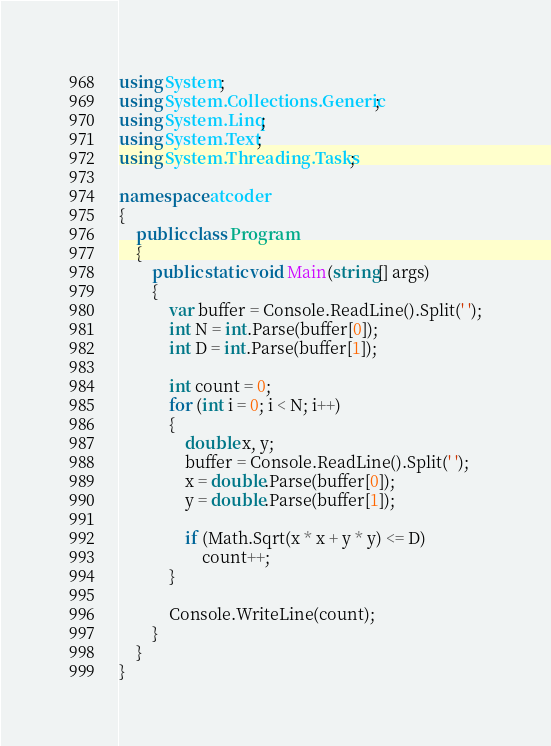Convert code to text. <code><loc_0><loc_0><loc_500><loc_500><_C#_>using System;
using System.Collections.Generic;
using System.Linq;
using System.Text;
using System.Threading.Tasks;

namespace atcoder
{
    public class Program
    {
        public static void Main(string[] args)
        {
            var buffer = Console.ReadLine().Split(' ');
            int N = int.Parse(buffer[0]);
            int D = int.Parse(buffer[1]);

            int count = 0;
            for (int i = 0; i < N; i++)
            {
                double x, y;
                buffer = Console.ReadLine().Split(' ');
                x = double.Parse(buffer[0]);
                y = double.Parse(buffer[1]);

                if (Math.Sqrt(x * x + y * y) <= D)
                    count++;
            }

            Console.WriteLine(count);
        }
    }
}
</code> 